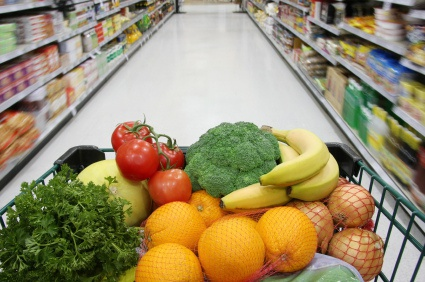Describe the objects in this image and their specific colors. I can see broccoli in gray, green, and darkgreen tones, orange in gray, orange, red, and gold tones, orange in gray, orange, red, and gold tones, banana in gray, khaki, and olive tones, and orange in gray, orange, and red tones in this image. 